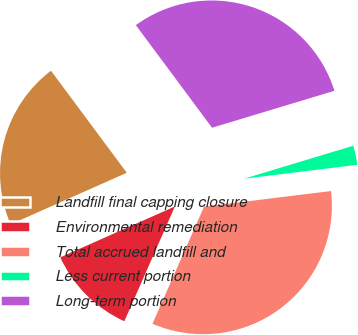<chart> <loc_0><loc_0><loc_500><loc_500><pie_chart><fcel>Landfill final capping closure<fcel>Environmental remediation<fcel>Total accrued landfill and<fcel>Less current portion<fcel>Long-term portion<nl><fcel>21.48%<fcel>11.74%<fcel>33.55%<fcel>2.72%<fcel>30.5%<nl></chart> 